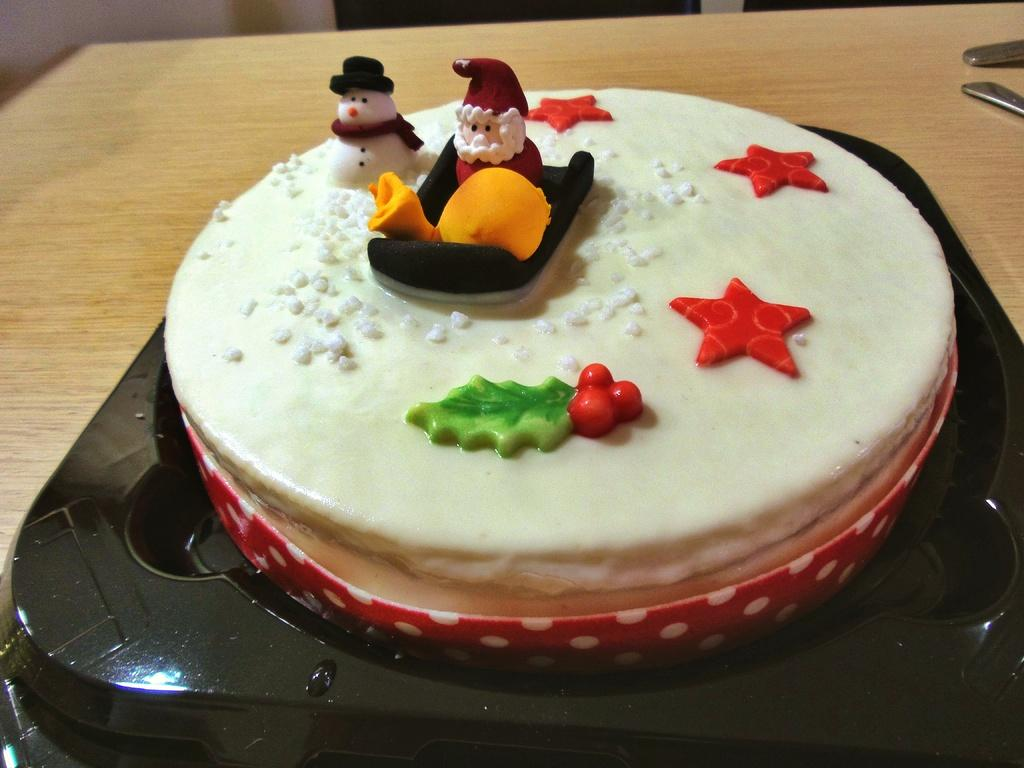Where was the image taken? The image was taken indoors. What furniture is present in the image? There is a table in the image. What utensils can be seen on the table? There are spoons on the table. What is placed on the table, besides the spoons? There is a tray on the table. What is on the tray? There is a cake on the tray. What time is displayed on the clock in the image? There is no clock present in the image. How many volleyballs are visible on the table in the image? There are no volleyballs present in the image; the image features a cake on a tray. 